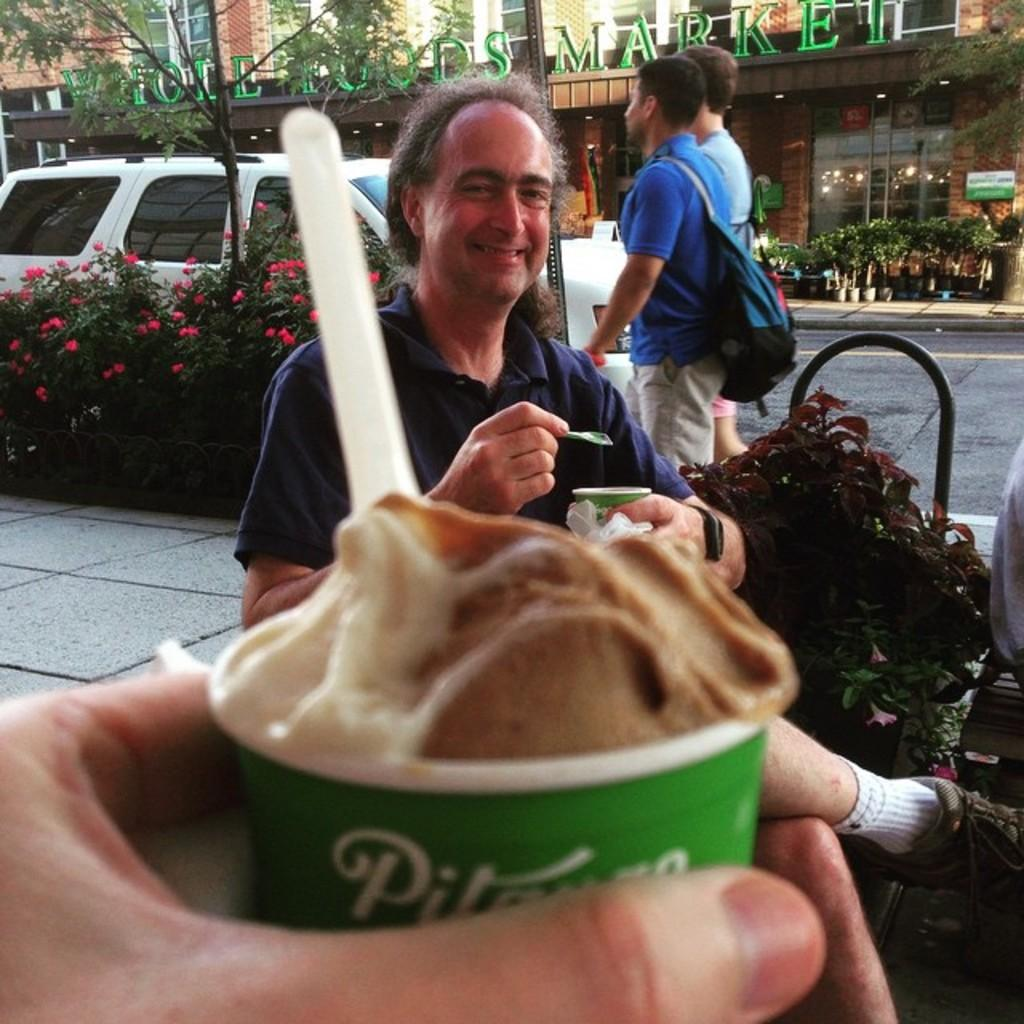How many people are in the image? There is a group of people in the image. What type of vegetation can be seen in the image? There are plants and flowers in the image. What mode of transportation is present in the image? There is a bus in the image. What type of structures are visible in the image? There are buildings in the image. What is the person holding in the image? The person is holding a cup in the image. What is inside the cup? The cup contains ice cream. How many dimes can be seen on the ground in the image? There are no dimes visible on the ground in the image. What type of dolls are sitting on the bus in the image? There are no dolls present in the image. 